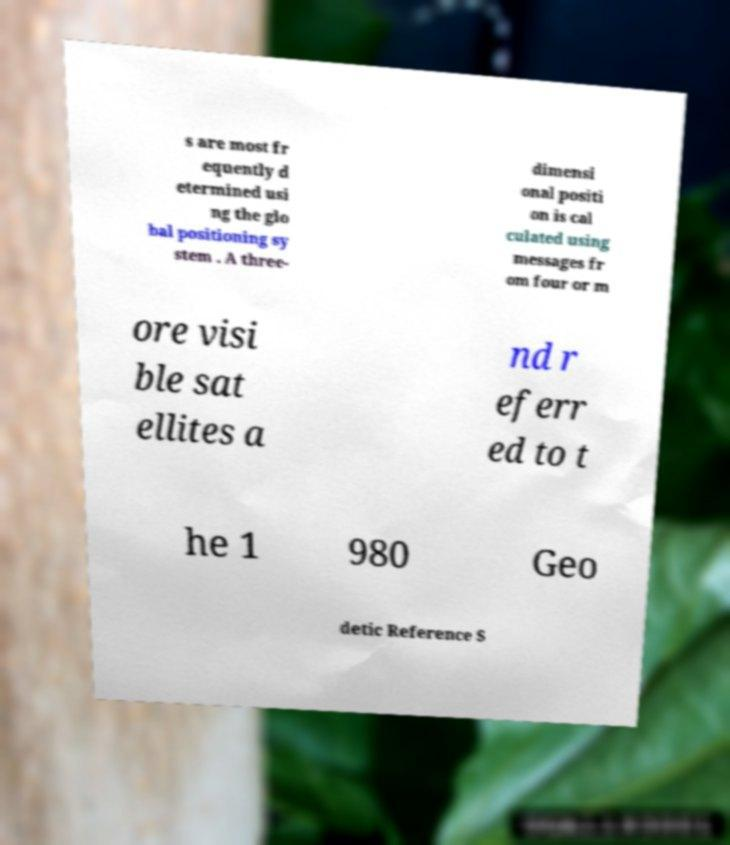There's text embedded in this image that I need extracted. Can you transcribe it verbatim? s are most fr equently d etermined usi ng the glo bal positioning sy stem . A three- dimensi onal positi on is cal culated using messages fr om four or m ore visi ble sat ellites a nd r eferr ed to t he 1 980 Geo detic Reference S 